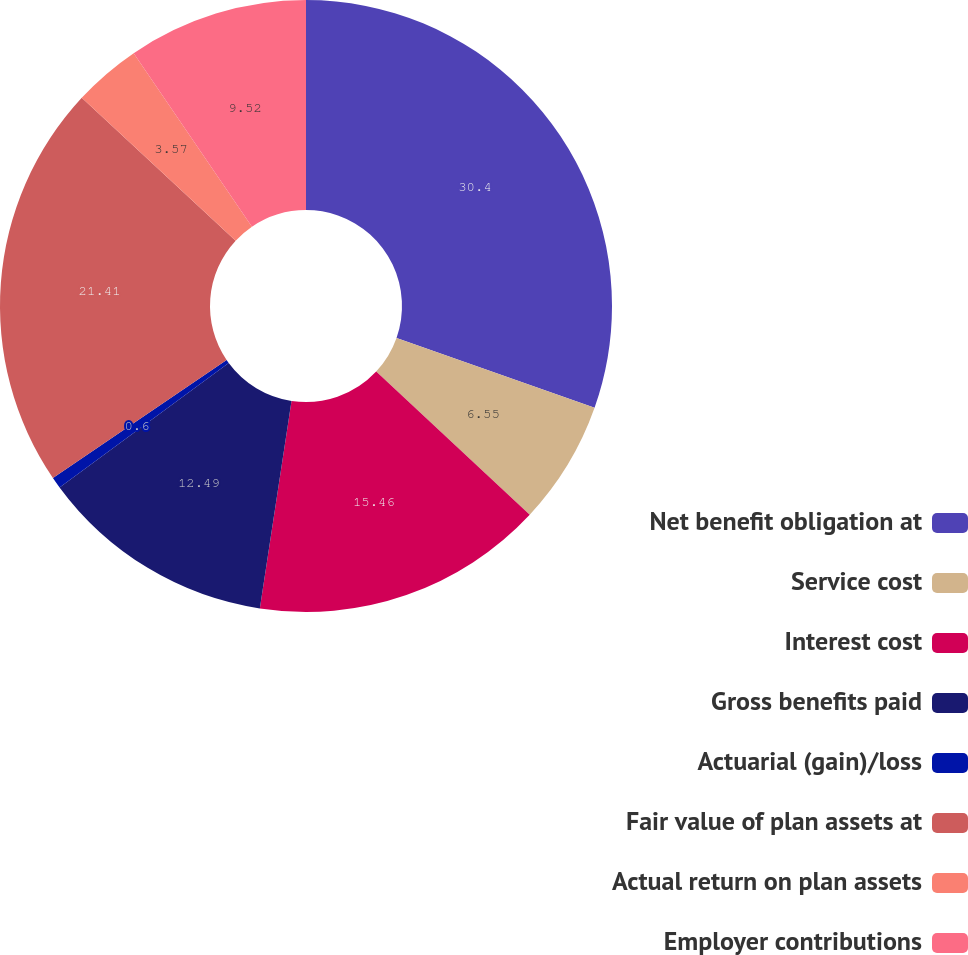<chart> <loc_0><loc_0><loc_500><loc_500><pie_chart><fcel>Net benefit obligation at<fcel>Service cost<fcel>Interest cost<fcel>Gross benefits paid<fcel>Actuarial (gain)/loss<fcel>Fair value of plan assets at<fcel>Actual return on plan assets<fcel>Employer contributions<nl><fcel>30.4%<fcel>6.55%<fcel>15.46%<fcel>12.49%<fcel>0.6%<fcel>21.41%<fcel>3.57%<fcel>9.52%<nl></chart> 